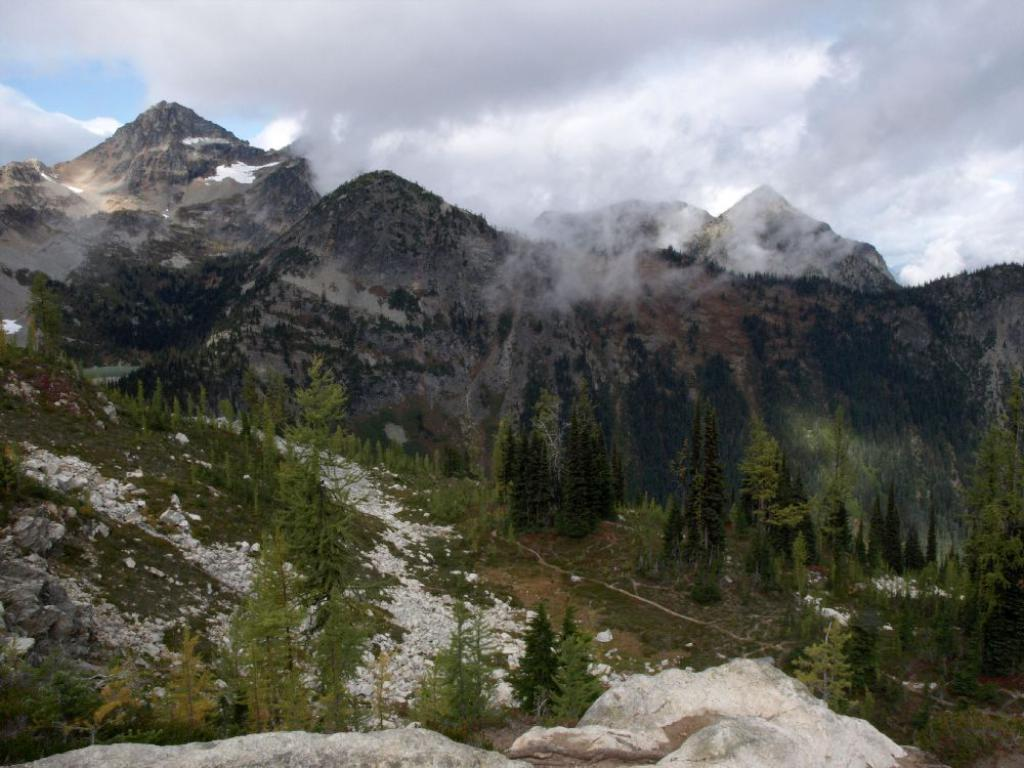What type of natural elements can be seen in the image? There are trees, rocks, and mountains in the image. What else is present in the image besides natural elements? A: There are objects in the image. What can be seen in the background of the image? The sky is visible in the background of the image. What is the condition of the sky in the image? Clouds are present in the sky. What type of pollution can be seen in the image? There is no pollution visible in the image; it features natural elements such as trees, rocks, and mountains. What type of songs are being sung by the flock of birds in the image? There are no birds or songs present in the image. 